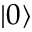<formula> <loc_0><loc_0><loc_500><loc_500>\left | 0 \right \rangle</formula> 